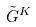<formula> <loc_0><loc_0><loc_500><loc_500>\tilde { G } ^ { K }</formula> 